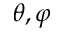Convert formula to latex. <formula><loc_0><loc_0><loc_500><loc_500>\theta , \varphi</formula> 